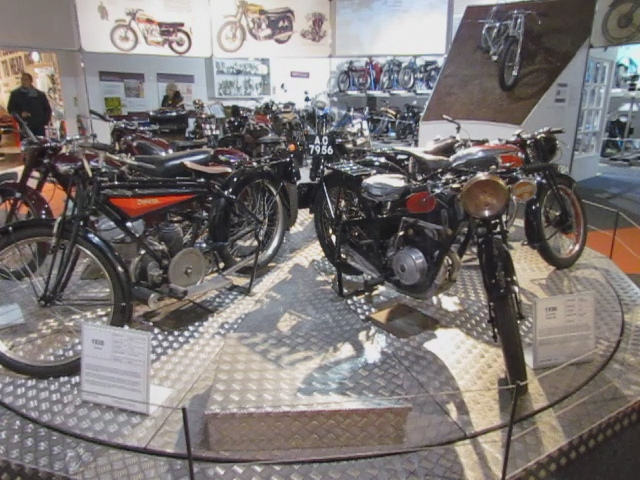Please transcribe the text in this image. 7986 